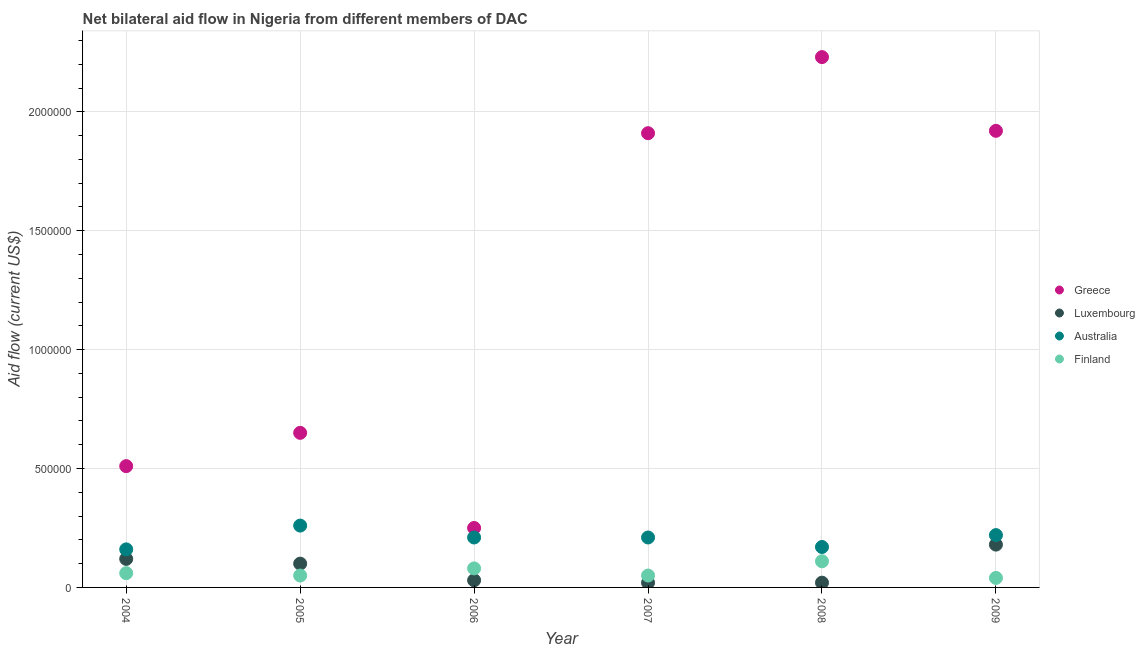What is the amount of aid given by greece in 2009?
Keep it short and to the point. 1.92e+06. Across all years, what is the maximum amount of aid given by greece?
Keep it short and to the point. 2.23e+06. Across all years, what is the minimum amount of aid given by greece?
Make the answer very short. 2.50e+05. What is the total amount of aid given by australia in the graph?
Provide a short and direct response. 1.23e+06. What is the difference between the amount of aid given by finland in 2004 and that in 2008?
Make the answer very short. -5.00e+04. What is the difference between the amount of aid given by finland in 2009 and the amount of aid given by greece in 2008?
Your response must be concise. -2.19e+06. What is the average amount of aid given by australia per year?
Provide a short and direct response. 2.05e+05. In the year 2008, what is the difference between the amount of aid given by finland and amount of aid given by greece?
Your response must be concise. -2.12e+06. What is the ratio of the amount of aid given by luxembourg in 2004 to that in 2009?
Your answer should be compact. 0.67. What is the difference between the highest and the lowest amount of aid given by australia?
Provide a short and direct response. 1.00e+05. Is it the case that in every year, the sum of the amount of aid given by greece and amount of aid given by luxembourg is greater than the amount of aid given by australia?
Give a very brief answer. Yes. Does the amount of aid given by finland monotonically increase over the years?
Offer a very short reply. No. What is the difference between two consecutive major ticks on the Y-axis?
Give a very brief answer. 5.00e+05. Does the graph contain any zero values?
Keep it short and to the point. No. Does the graph contain grids?
Your answer should be very brief. Yes. Where does the legend appear in the graph?
Offer a very short reply. Center right. How are the legend labels stacked?
Make the answer very short. Vertical. What is the title of the graph?
Ensure brevity in your answer.  Net bilateral aid flow in Nigeria from different members of DAC. Does "Gender equality" appear as one of the legend labels in the graph?
Provide a succinct answer. No. What is the label or title of the Y-axis?
Give a very brief answer. Aid flow (current US$). What is the Aid flow (current US$) in Greece in 2004?
Your answer should be very brief. 5.10e+05. What is the Aid flow (current US$) in Greece in 2005?
Your response must be concise. 6.50e+05. What is the Aid flow (current US$) in Finland in 2005?
Offer a very short reply. 5.00e+04. What is the Aid flow (current US$) in Luxembourg in 2006?
Provide a succinct answer. 3.00e+04. What is the Aid flow (current US$) of Greece in 2007?
Provide a succinct answer. 1.91e+06. What is the Aid flow (current US$) of Luxembourg in 2007?
Provide a succinct answer. 2.00e+04. What is the Aid flow (current US$) in Greece in 2008?
Keep it short and to the point. 2.23e+06. What is the Aid flow (current US$) in Australia in 2008?
Give a very brief answer. 1.70e+05. What is the Aid flow (current US$) of Greece in 2009?
Provide a short and direct response. 1.92e+06. What is the Aid flow (current US$) in Luxembourg in 2009?
Your answer should be very brief. 1.80e+05. What is the Aid flow (current US$) of Australia in 2009?
Provide a succinct answer. 2.20e+05. Across all years, what is the maximum Aid flow (current US$) in Greece?
Your answer should be very brief. 2.23e+06. Across all years, what is the minimum Aid flow (current US$) of Greece?
Your answer should be compact. 2.50e+05. Across all years, what is the minimum Aid flow (current US$) of Luxembourg?
Keep it short and to the point. 2.00e+04. Across all years, what is the minimum Aid flow (current US$) in Australia?
Your answer should be compact. 1.60e+05. Across all years, what is the minimum Aid flow (current US$) in Finland?
Offer a very short reply. 4.00e+04. What is the total Aid flow (current US$) in Greece in the graph?
Keep it short and to the point. 7.47e+06. What is the total Aid flow (current US$) in Australia in the graph?
Your answer should be compact. 1.23e+06. What is the difference between the Aid flow (current US$) of Greece in 2004 and that in 2005?
Ensure brevity in your answer.  -1.40e+05. What is the difference between the Aid flow (current US$) in Luxembourg in 2004 and that in 2005?
Give a very brief answer. 2.00e+04. What is the difference between the Aid flow (current US$) of Australia in 2004 and that in 2005?
Your answer should be very brief. -1.00e+05. What is the difference between the Aid flow (current US$) of Luxembourg in 2004 and that in 2006?
Your answer should be very brief. 9.00e+04. What is the difference between the Aid flow (current US$) of Greece in 2004 and that in 2007?
Offer a terse response. -1.40e+06. What is the difference between the Aid flow (current US$) of Luxembourg in 2004 and that in 2007?
Provide a succinct answer. 1.00e+05. What is the difference between the Aid flow (current US$) in Australia in 2004 and that in 2007?
Make the answer very short. -5.00e+04. What is the difference between the Aid flow (current US$) of Finland in 2004 and that in 2007?
Provide a short and direct response. 10000. What is the difference between the Aid flow (current US$) of Greece in 2004 and that in 2008?
Your answer should be compact. -1.72e+06. What is the difference between the Aid flow (current US$) of Luxembourg in 2004 and that in 2008?
Keep it short and to the point. 1.00e+05. What is the difference between the Aid flow (current US$) in Australia in 2004 and that in 2008?
Your response must be concise. -10000. What is the difference between the Aid flow (current US$) of Finland in 2004 and that in 2008?
Offer a terse response. -5.00e+04. What is the difference between the Aid flow (current US$) of Greece in 2004 and that in 2009?
Your answer should be very brief. -1.41e+06. What is the difference between the Aid flow (current US$) in Greece in 2005 and that in 2006?
Offer a terse response. 4.00e+05. What is the difference between the Aid flow (current US$) of Luxembourg in 2005 and that in 2006?
Ensure brevity in your answer.  7.00e+04. What is the difference between the Aid flow (current US$) of Finland in 2005 and that in 2006?
Your answer should be compact. -3.00e+04. What is the difference between the Aid flow (current US$) in Greece in 2005 and that in 2007?
Your answer should be compact. -1.26e+06. What is the difference between the Aid flow (current US$) of Australia in 2005 and that in 2007?
Provide a short and direct response. 5.00e+04. What is the difference between the Aid flow (current US$) of Finland in 2005 and that in 2007?
Provide a succinct answer. 0. What is the difference between the Aid flow (current US$) in Greece in 2005 and that in 2008?
Provide a short and direct response. -1.58e+06. What is the difference between the Aid flow (current US$) of Australia in 2005 and that in 2008?
Your response must be concise. 9.00e+04. What is the difference between the Aid flow (current US$) of Finland in 2005 and that in 2008?
Your answer should be compact. -6.00e+04. What is the difference between the Aid flow (current US$) of Greece in 2005 and that in 2009?
Provide a succinct answer. -1.27e+06. What is the difference between the Aid flow (current US$) in Luxembourg in 2005 and that in 2009?
Your answer should be very brief. -8.00e+04. What is the difference between the Aid flow (current US$) in Australia in 2005 and that in 2009?
Give a very brief answer. 4.00e+04. What is the difference between the Aid flow (current US$) of Greece in 2006 and that in 2007?
Provide a succinct answer. -1.66e+06. What is the difference between the Aid flow (current US$) in Luxembourg in 2006 and that in 2007?
Your answer should be very brief. 10000. What is the difference between the Aid flow (current US$) of Greece in 2006 and that in 2008?
Ensure brevity in your answer.  -1.98e+06. What is the difference between the Aid flow (current US$) in Luxembourg in 2006 and that in 2008?
Your answer should be compact. 10000. What is the difference between the Aid flow (current US$) of Australia in 2006 and that in 2008?
Provide a succinct answer. 4.00e+04. What is the difference between the Aid flow (current US$) in Finland in 2006 and that in 2008?
Provide a succinct answer. -3.00e+04. What is the difference between the Aid flow (current US$) of Greece in 2006 and that in 2009?
Give a very brief answer. -1.67e+06. What is the difference between the Aid flow (current US$) of Luxembourg in 2006 and that in 2009?
Provide a short and direct response. -1.50e+05. What is the difference between the Aid flow (current US$) of Australia in 2006 and that in 2009?
Your answer should be compact. -10000. What is the difference between the Aid flow (current US$) of Greece in 2007 and that in 2008?
Offer a terse response. -3.20e+05. What is the difference between the Aid flow (current US$) in Australia in 2007 and that in 2008?
Your answer should be compact. 4.00e+04. What is the difference between the Aid flow (current US$) in Luxembourg in 2007 and that in 2009?
Keep it short and to the point. -1.60e+05. What is the difference between the Aid flow (current US$) of Australia in 2007 and that in 2009?
Your answer should be very brief. -10000. What is the difference between the Aid flow (current US$) in Greece in 2008 and that in 2009?
Make the answer very short. 3.10e+05. What is the difference between the Aid flow (current US$) in Luxembourg in 2008 and that in 2009?
Ensure brevity in your answer.  -1.60e+05. What is the difference between the Aid flow (current US$) in Australia in 2008 and that in 2009?
Give a very brief answer. -5.00e+04. What is the difference between the Aid flow (current US$) in Finland in 2008 and that in 2009?
Give a very brief answer. 7.00e+04. What is the difference between the Aid flow (current US$) in Greece in 2004 and the Aid flow (current US$) in Australia in 2005?
Your answer should be compact. 2.50e+05. What is the difference between the Aid flow (current US$) in Luxembourg in 2004 and the Aid flow (current US$) in Australia in 2005?
Offer a terse response. -1.40e+05. What is the difference between the Aid flow (current US$) in Luxembourg in 2004 and the Aid flow (current US$) in Finland in 2005?
Offer a very short reply. 7.00e+04. What is the difference between the Aid flow (current US$) of Greece in 2004 and the Aid flow (current US$) of Luxembourg in 2006?
Provide a short and direct response. 4.80e+05. What is the difference between the Aid flow (current US$) in Greece in 2004 and the Aid flow (current US$) in Australia in 2006?
Ensure brevity in your answer.  3.00e+05. What is the difference between the Aid flow (current US$) of Greece in 2004 and the Aid flow (current US$) of Finland in 2006?
Your answer should be compact. 4.30e+05. What is the difference between the Aid flow (current US$) of Luxembourg in 2004 and the Aid flow (current US$) of Australia in 2006?
Ensure brevity in your answer.  -9.00e+04. What is the difference between the Aid flow (current US$) in Luxembourg in 2004 and the Aid flow (current US$) in Finland in 2006?
Offer a very short reply. 4.00e+04. What is the difference between the Aid flow (current US$) of Greece in 2004 and the Aid flow (current US$) of Australia in 2008?
Your response must be concise. 3.40e+05. What is the difference between the Aid flow (current US$) in Greece in 2004 and the Aid flow (current US$) in Finland in 2008?
Keep it short and to the point. 4.00e+05. What is the difference between the Aid flow (current US$) in Luxembourg in 2004 and the Aid flow (current US$) in Australia in 2008?
Offer a very short reply. -5.00e+04. What is the difference between the Aid flow (current US$) of Greece in 2004 and the Aid flow (current US$) of Luxembourg in 2009?
Your answer should be very brief. 3.30e+05. What is the difference between the Aid flow (current US$) of Greece in 2004 and the Aid flow (current US$) of Finland in 2009?
Provide a succinct answer. 4.70e+05. What is the difference between the Aid flow (current US$) of Luxembourg in 2004 and the Aid flow (current US$) of Australia in 2009?
Keep it short and to the point. -1.00e+05. What is the difference between the Aid flow (current US$) in Australia in 2004 and the Aid flow (current US$) in Finland in 2009?
Keep it short and to the point. 1.20e+05. What is the difference between the Aid flow (current US$) in Greece in 2005 and the Aid flow (current US$) in Luxembourg in 2006?
Make the answer very short. 6.20e+05. What is the difference between the Aid flow (current US$) in Greece in 2005 and the Aid flow (current US$) in Australia in 2006?
Your answer should be very brief. 4.40e+05. What is the difference between the Aid flow (current US$) of Greece in 2005 and the Aid flow (current US$) of Finland in 2006?
Ensure brevity in your answer.  5.70e+05. What is the difference between the Aid flow (current US$) of Luxembourg in 2005 and the Aid flow (current US$) of Finland in 2006?
Ensure brevity in your answer.  2.00e+04. What is the difference between the Aid flow (current US$) in Australia in 2005 and the Aid flow (current US$) in Finland in 2006?
Provide a short and direct response. 1.80e+05. What is the difference between the Aid flow (current US$) of Greece in 2005 and the Aid flow (current US$) of Luxembourg in 2007?
Keep it short and to the point. 6.30e+05. What is the difference between the Aid flow (current US$) in Greece in 2005 and the Aid flow (current US$) in Australia in 2007?
Your answer should be very brief. 4.40e+05. What is the difference between the Aid flow (current US$) in Luxembourg in 2005 and the Aid flow (current US$) in Finland in 2007?
Your response must be concise. 5.00e+04. What is the difference between the Aid flow (current US$) of Greece in 2005 and the Aid flow (current US$) of Luxembourg in 2008?
Offer a terse response. 6.30e+05. What is the difference between the Aid flow (current US$) of Greece in 2005 and the Aid flow (current US$) of Australia in 2008?
Offer a terse response. 4.80e+05. What is the difference between the Aid flow (current US$) in Greece in 2005 and the Aid flow (current US$) in Finland in 2008?
Make the answer very short. 5.40e+05. What is the difference between the Aid flow (current US$) in Australia in 2005 and the Aid flow (current US$) in Finland in 2008?
Offer a very short reply. 1.50e+05. What is the difference between the Aid flow (current US$) of Greece in 2005 and the Aid flow (current US$) of Australia in 2009?
Make the answer very short. 4.30e+05. What is the difference between the Aid flow (current US$) of Greece in 2005 and the Aid flow (current US$) of Finland in 2009?
Your response must be concise. 6.10e+05. What is the difference between the Aid flow (current US$) of Greece in 2006 and the Aid flow (current US$) of Luxembourg in 2007?
Make the answer very short. 2.30e+05. What is the difference between the Aid flow (current US$) of Greece in 2006 and the Aid flow (current US$) of Finland in 2007?
Your answer should be compact. 2.00e+05. What is the difference between the Aid flow (current US$) of Luxembourg in 2006 and the Aid flow (current US$) of Australia in 2007?
Provide a succinct answer. -1.80e+05. What is the difference between the Aid flow (current US$) in Luxembourg in 2006 and the Aid flow (current US$) in Finland in 2007?
Your response must be concise. -2.00e+04. What is the difference between the Aid flow (current US$) of Australia in 2006 and the Aid flow (current US$) of Finland in 2007?
Your answer should be compact. 1.60e+05. What is the difference between the Aid flow (current US$) in Greece in 2006 and the Aid flow (current US$) in Australia in 2008?
Offer a terse response. 8.00e+04. What is the difference between the Aid flow (current US$) in Greece in 2006 and the Aid flow (current US$) in Finland in 2008?
Provide a short and direct response. 1.40e+05. What is the difference between the Aid flow (current US$) of Australia in 2006 and the Aid flow (current US$) of Finland in 2008?
Provide a short and direct response. 1.00e+05. What is the difference between the Aid flow (current US$) in Greece in 2006 and the Aid flow (current US$) in Luxembourg in 2009?
Your answer should be compact. 7.00e+04. What is the difference between the Aid flow (current US$) in Greece in 2006 and the Aid flow (current US$) in Finland in 2009?
Make the answer very short. 2.10e+05. What is the difference between the Aid flow (current US$) of Luxembourg in 2006 and the Aid flow (current US$) of Australia in 2009?
Your answer should be compact. -1.90e+05. What is the difference between the Aid flow (current US$) in Luxembourg in 2006 and the Aid flow (current US$) in Finland in 2009?
Give a very brief answer. -10000. What is the difference between the Aid flow (current US$) of Greece in 2007 and the Aid flow (current US$) of Luxembourg in 2008?
Your answer should be compact. 1.89e+06. What is the difference between the Aid flow (current US$) in Greece in 2007 and the Aid flow (current US$) in Australia in 2008?
Make the answer very short. 1.74e+06. What is the difference between the Aid flow (current US$) in Greece in 2007 and the Aid flow (current US$) in Finland in 2008?
Your answer should be very brief. 1.80e+06. What is the difference between the Aid flow (current US$) of Luxembourg in 2007 and the Aid flow (current US$) of Finland in 2008?
Your answer should be compact. -9.00e+04. What is the difference between the Aid flow (current US$) of Greece in 2007 and the Aid flow (current US$) of Luxembourg in 2009?
Offer a very short reply. 1.73e+06. What is the difference between the Aid flow (current US$) in Greece in 2007 and the Aid flow (current US$) in Australia in 2009?
Make the answer very short. 1.69e+06. What is the difference between the Aid flow (current US$) in Greece in 2007 and the Aid flow (current US$) in Finland in 2009?
Offer a very short reply. 1.87e+06. What is the difference between the Aid flow (current US$) in Luxembourg in 2007 and the Aid flow (current US$) in Australia in 2009?
Your response must be concise. -2.00e+05. What is the difference between the Aid flow (current US$) of Luxembourg in 2007 and the Aid flow (current US$) of Finland in 2009?
Provide a succinct answer. -2.00e+04. What is the difference between the Aid flow (current US$) in Australia in 2007 and the Aid flow (current US$) in Finland in 2009?
Provide a short and direct response. 1.70e+05. What is the difference between the Aid flow (current US$) in Greece in 2008 and the Aid flow (current US$) in Luxembourg in 2009?
Provide a short and direct response. 2.05e+06. What is the difference between the Aid flow (current US$) in Greece in 2008 and the Aid flow (current US$) in Australia in 2009?
Offer a very short reply. 2.01e+06. What is the difference between the Aid flow (current US$) of Greece in 2008 and the Aid flow (current US$) of Finland in 2009?
Your answer should be compact. 2.19e+06. What is the difference between the Aid flow (current US$) in Luxembourg in 2008 and the Aid flow (current US$) in Australia in 2009?
Ensure brevity in your answer.  -2.00e+05. What is the difference between the Aid flow (current US$) of Luxembourg in 2008 and the Aid flow (current US$) of Finland in 2009?
Your answer should be very brief. -2.00e+04. What is the average Aid flow (current US$) in Greece per year?
Provide a succinct answer. 1.24e+06. What is the average Aid flow (current US$) in Luxembourg per year?
Offer a terse response. 7.83e+04. What is the average Aid flow (current US$) of Australia per year?
Provide a succinct answer. 2.05e+05. What is the average Aid flow (current US$) of Finland per year?
Offer a terse response. 6.50e+04. In the year 2004, what is the difference between the Aid flow (current US$) of Greece and Aid flow (current US$) of Australia?
Make the answer very short. 3.50e+05. In the year 2004, what is the difference between the Aid flow (current US$) of Luxembourg and Aid flow (current US$) of Finland?
Offer a very short reply. 6.00e+04. In the year 2006, what is the difference between the Aid flow (current US$) of Greece and Aid flow (current US$) of Luxembourg?
Offer a terse response. 2.20e+05. In the year 2006, what is the difference between the Aid flow (current US$) in Australia and Aid flow (current US$) in Finland?
Your answer should be very brief. 1.30e+05. In the year 2007, what is the difference between the Aid flow (current US$) of Greece and Aid flow (current US$) of Luxembourg?
Your answer should be very brief. 1.89e+06. In the year 2007, what is the difference between the Aid flow (current US$) in Greece and Aid flow (current US$) in Australia?
Offer a very short reply. 1.70e+06. In the year 2007, what is the difference between the Aid flow (current US$) of Greece and Aid flow (current US$) of Finland?
Make the answer very short. 1.86e+06. In the year 2008, what is the difference between the Aid flow (current US$) of Greece and Aid flow (current US$) of Luxembourg?
Offer a very short reply. 2.21e+06. In the year 2008, what is the difference between the Aid flow (current US$) in Greece and Aid flow (current US$) in Australia?
Offer a terse response. 2.06e+06. In the year 2008, what is the difference between the Aid flow (current US$) of Greece and Aid flow (current US$) of Finland?
Make the answer very short. 2.12e+06. In the year 2008, what is the difference between the Aid flow (current US$) in Luxembourg and Aid flow (current US$) in Australia?
Your answer should be very brief. -1.50e+05. In the year 2008, what is the difference between the Aid flow (current US$) in Australia and Aid flow (current US$) in Finland?
Your answer should be compact. 6.00e+04. In the year 2009, what is the difference between the Aid flow (current US$) of Greece and Aid flow (current US$) of Luxembourg?
Make the answer very short. 1.74e+06. In the year 2009, what is the difference between the Aid flow (current US$) of Greece and Aid flow (current US$) of Australia?
Provide a succinct answer. 1.70e+06. In the year 2009, what is the difference between the Aid flow (current US$) of Greece and Aid flow (current US$) of Finland?
Keep it short and to the point. 1.88e+06. In the year 2009, what is the difference between the Aid flow (current US$) in Luxembourg and Aid flow (current US$) in Finland?
Offer a very short reply. 1.40e+05. In the year 2009, what is the difference between the Aid flow (current US$) in Australia and Aid flow (current US$) in Finland?
Provide a short and direct response. 1.80e+05. What is the ratio of the Aid flow (current US$) of Greece in 2004 to that in 2005?
Give a very brief answer. 0.78. What is the ratio of the Aid flow (current US$) in Luxembourg in 2004 to that in 2005?
Offer a very short reply. 1.2. What is the ratio of the Aid flow (current US$) of Australia in 2004 to that in 2005?
Your response must be concise. 0.62. What is the ratio of the Aid flow (current US$) in Finland in 2004 to that in 2005?
Your answer should be very brief. 1.2. What is the ratio of the Aid flow (current US$) of Greece in 2004 to that in 2006?
Provide a succinct answer. 2.04. What is the ratio of the Aid flow (current US$) of Australia in 2004 to that in 2006?
Provide a short and direct response. 0.76. What is the ratio of the Aid flow (current US$) of Greece in 2004 to that in 2007?
Provide a short and direct response. 0.27. What is the ratio of the Aid flow (current US$) of Australia in 2004 to that in 2007?
Offer a very short reply. 0.76. What is the ratio of the Aid flow (current US$) in Finland in 2004 to that in 2007?
Give a very brief answer. 1.2. What is the ratio of the Aid flow (current US$) of Greece in 2004 to that in 2008?
Your answer should be very brief. 0.23. What is the ratio of the Aid flow (current US$) of Australia in 2004 to that in 2008?
Provide a short and direct response. 0.94. What is the ratio of the Aid flow (current US$) of Finland in 2004 to that in 2008?
Offer a very short reply. 0.55. What is the ratio of the Aid flow (current US$) of Greece in 2004 to that in 2009?
Offer a terse response. 0.27. What is the ratio of the Aid flow (current US$) in Australia in 2004 to that in 2009?
Provide a succinct answer. 0.73. What is the ratio of the Aid flow (current US$) in Greece in 2005 to that in 2006?
Your answer should be very brief. 2.6. What is the ratio of the Aid flow (current US$) in Australia in 2005 to that in 2006?
Your response must be concise. 1.24. What is the ratio of the Aid flow (current US$) in Greece in 2005 to that in 2007?
Your answer should be compact. 0.34. What is the ratio of the Aid flow (current US$) of Luxembourg in 2005 to that in 2007?
Your answer should be very brief. 5. What is the ratio of the Aid flow (current US$) in Australia in 2005 to that in 2007?
Provide a short and direct response. 1.24. What is the ratio of the Aid flow (current US$) in Greece in 2005 to that in 2008?
Offer a very short reply. 0.29. What is the ratio of the Aid flow (current US$) of Australia in 2005 to that in 2008?
Offer a terse response. 1.53. What is the ratio of the Aid flow (current US$) in Finland in 2005 to that in 2008?
Keep it short and to the point. 0.45. What is the ratio of the Aid flow (current US$) of Greece in 2005 to that in 2009?
Provide a succinct answer. 0.34. What is the ratio of the Aid flow (current US$) of Luxembourg in 2005 to that in 2009?
Give a very brief answer. 0.56. What is the ratio of the Aid flow (current US$) in Australia in 2005 to that in 2009?
Keep it short and to the point. 1.18. What is the ratio of the Aid flow (current US$) in Greece in 2006 to that in 2007?
Provide a succinct answer. 0.13. What is the ratio of the Aid flow (current US$) in Luxembourg in 2006 to that in 2007?
Offer a very short reply. 1.5. What is the ratio of the Aid flow (current US$) of Greece in 2006 to that in 2008?
Ensure brevity in your answer.  0.11. What is the ratio of the Aid flow (current US$) of Australia in 2006 to that in 2008?
Your answer should be very brief. 1.24. What is the ratio of the Aid flow (current US$) in Finland in 2006 to that in 2008?
Your answer should be very brief. 0.73. What is the ratio of the Aid flow (current US$) of Greece in 2006 to that in 2009?
Your answer should be compact. 0.13. What is the ratio of the Aid flow (current US$) of Australia in 2006 to that in 2009?
Offer a very short reply. 0.95. What is the ratio of the Aid flow (current US$) in Greece in 2007 to that in 2008?
Provide a short and direct response. 0.86. What is the ratio of the Aid flow (current US$) of Luxembourg in 2007 to that in 2008?
Give a very brief answer. 1. What is the ratio of the Aid flow (current US$) of Australia in 2007 to that in 2008?
Your answer should be compact. 1.24. What is the ratio of the Aid flow (current US$) of Finland in 2007 to that in 2008?
Offer a very short reply. 0.45. What is the ratio of the Aid flow (current US$) of Greece in 2007 to that in 2009?
Your answer should be very brief. 0.99. What is the ratio of the Aid flow (current US$) of Australia in 2007 to that in 2009?
Your response must be concise. 0.95. What is the ratio of the Aid flow (current US$) of Finland in 2007 to that in 2009?
Ensure brevity in your answer.  1.25. What is the ratio of the Aid flow (current US$) in Greece in 2008 to that in 2009?
Offer a very short reply. 1.16. What is the ratio of the Aid flow (current US$) in Luxembourg in 2008 to that in 2009?
Keep it short and to the point. 0.11. What is the ratio of the Aid flow (current US$) of Australia in 2008 to that in 2009?
Keep it short and to the point. 0.77. What is the ratio of the Aid flow (current US$) in Finland in 2008 to that in 2009?
Your response must be concise. 2.75. What is the difference between the highest and the second highest Aid flow (current US$) of Greece?
Your answer should be very brief. 3.10e+05. What is the difference between the highest and the second highest Aid flow (current US$) of Luxembourg?
Offer a very short reply. 6.00e+04. What is the difference between the highest and the second highest Aid flow (current US$) of Finland?
Your response must be concise. 3.00e+04. What is the difference between the highest and the lowest Aid flow (current US$) of Greece?
Provide a succinct answer. 1.98e+06. What is the difference between the highest and the lowest Aid flow (current US$) of Australia?
Offer a very short reply. 1.00e+05. 